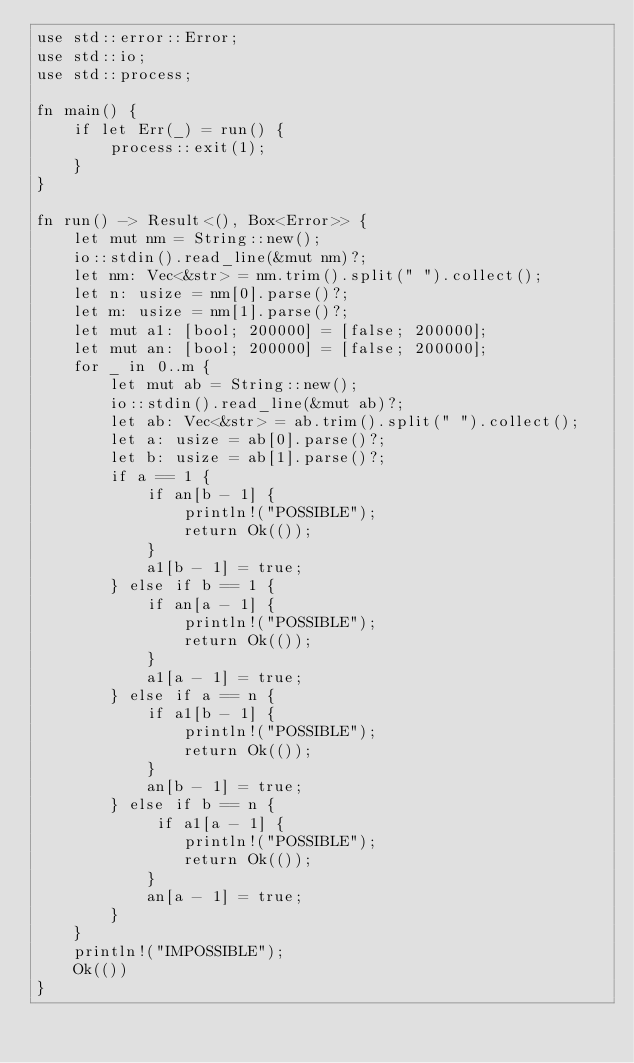<code> <loc_0><loc_0><loc_500><loc_500><_Rust_>use std::error::Error;
use std::io;
use std::process;

fn main() {
    if let Err(_) = run() {
        process::exit(1);
    }
}

fn run() -> Result<(), Box<Error>> {
    let mut nm = String::new();
    io::stdin().read_line(&mut nm)?;
    let nm: Vec<&str> = nm.trim().split(" ").collect();
    let n: usize = nm[0].parse()?;
    let m: usize = nm[1].parse()?;
    let mut a1: [bool; 200000] = [false; 200000];
    let mut an: [bool; 200000] = [false; 200000];
    for _ in 0..m {
        let mut ab = String::new();
        io::stdin().read_line(&mut ab)?;
        let ab: Vec<&str> = ab.trim().split(" ").collect();
        let a: usize = ab[0].parse()?;
        let b: usize = ab[1].parse()?;
        if a == 1 {
            if an[b - 1] {
                println!("POSSIBLE");
                return Ok(());
            }
            a1[b - 1] = true;
        } else if b == 1 {
            if an[a - 1] {
                println!("POSSIBLE");
                return Ok(());
            }
            a1[a - 1] = true;
        } else if a == n {
            if a1[b - 1] {
                println!("POSSIBLE");
                return Ok(());
            }
            an[b - 1] = true;
        } else if b == n {
             if a1[a - 1] {
                println!("POSSIBLE");
                return Ok(());
            }
            an[a - 1] = true;
        }
    }
    println!("IMPOSSIBLE");
    Ok(())
}
</code> 